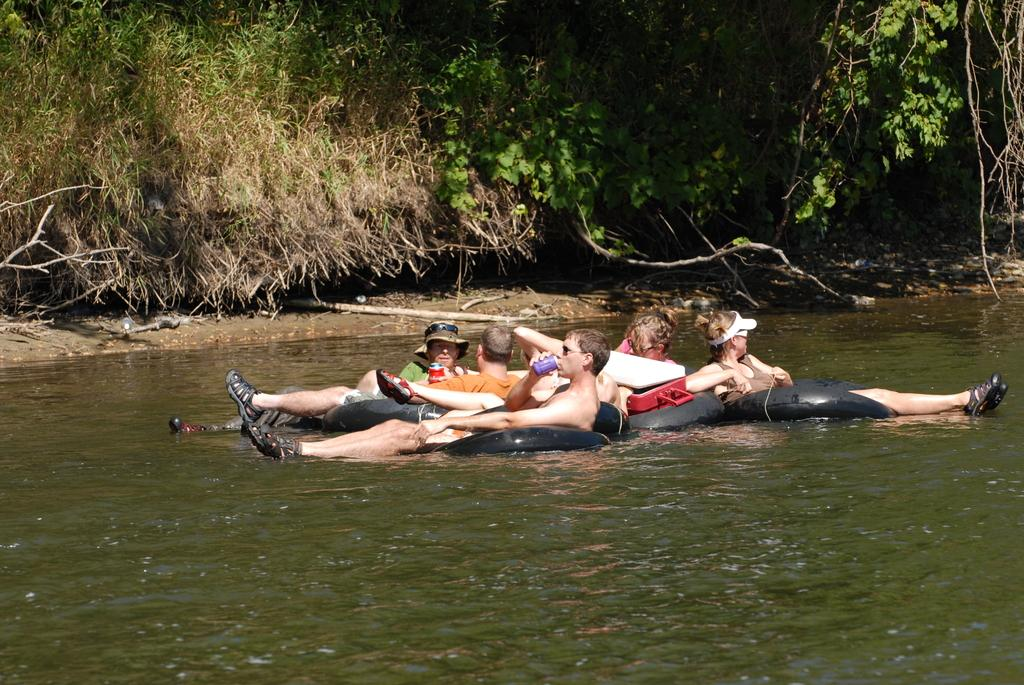What is happening to the group of people in the image? The people are floating on the water in the image. What can be seen in the background of the image? There are many trees around the group of people. What type of polish is being applied to the lamp in the image? There is no lamp or polish present in the image. How much credit is being discussed among the group of people in the image? There is no mention of credit or any financial discussion in the image. 